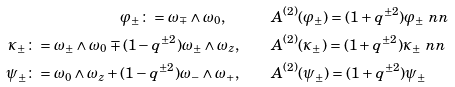<formula> <loc_0><loc_0><loc_500><loc_500>\varphi _ { \pm } \colon = \omega _ { \mp } \wedge \omega _ { 0 } , \quad & \quad A ^ { ( 2 ) } ( \varphi _ { \pm } ) = ( 1 + q ^ { \pm 2 } ) \varphi _ { \pm } \ n n \\ \kappa _ { \pm } \colon = \omega _ { \pm } \wedge \omega _ { 0 } \mp ( 1 - q ^ { \pm 2 } ) \omega _ { \pm } \wedge \omega _ { z } , \quad & \quad A ^ { ( 2 ) } ( \kappa _ { \pm } ) = ( 1 + q ^ { \pm 2 } ) \kappa _ { \pm } \ n n \\ \psi _ { \pm } \colon = \omega _ { 0 } \wedge \omega _ { z } + ( 1 - q ^ { \pm 2 } ) \omega _ { - } \wedge \omega _ { + } , \quad & \quad A ^ { ( 2 ) } ( \psi _ { \pm } ) = ( 1 + q ^ { \pm 2 } ) \psi _ { \pm }</formula> 